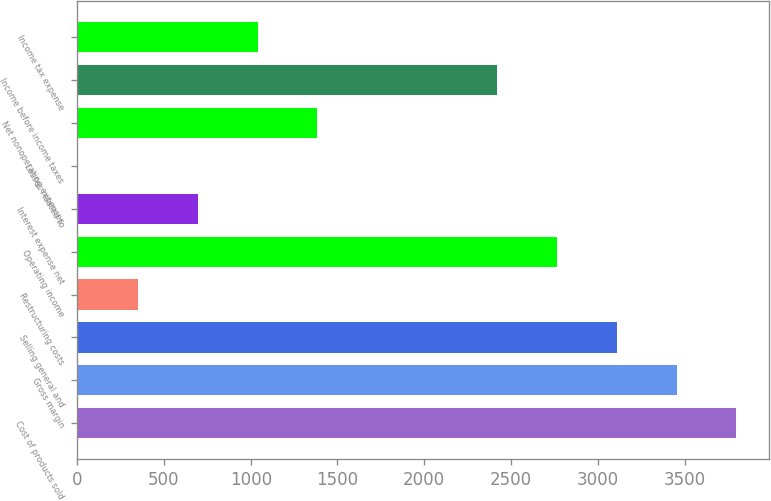<chart> <loc_0><loc_0><loc_500><loc_500><bar_chart><fcel>Cost of products sold<fcel>Gross margin<fcel>Selling general and<fcel>Restructuring costs<fcel>Operating income<fcel>Interest expense net<fcel>Losses related to<fcel>Net nonoperating expenses<fcel>Income before income taxes<fcel>Income tax expense<nl><fcel>3798.16<fcel>3453.3<fcel>3108.44<fcel>349.56<fcel>2763.58<fcel>694.42<fcel>4.7<fcel>1384.14<fcel>2418.72<fcel>1039.28<nl></chart> 